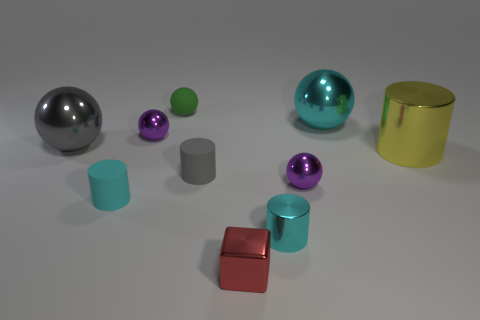What is the color of the large shiny cylinder?
Your response must be concise. Yellow. How many objects are on the left side of the yellow thing on the right side of the large gray metallic thing?
Offer a very short reply. 9. There is a purple metal object behind the large cylinder; is there a small red cube that is behind it?
Make the answer very short. No. Are there any small red shiny objects behind the big yellow metallic thing?
Provide a succinct answer. No. There is a purple thing right of the green matte sphere; is it the same shape as the green object?
Ensure brevity in your answer.  Yes. What number of yellow shiny objects are the same shape as the gray rubber object?
Give a very brief answer. 1. Are there any tiny purple cylinders that have the same material as the large gray sphere?
Your answer should be compact. No. What is the material of the object that is in front of the cyan metal object that is in front of the yellow cylinder?
Offer a terse response. Metal. What size is the purple metal sphere that is right of the small green rubber thing?
Keep it short and to the point. Small. There is a metal block; is it the same color as the matte cylinder that is in front of the tiny gray matte cylinder?
Offer a very short reply. No. 